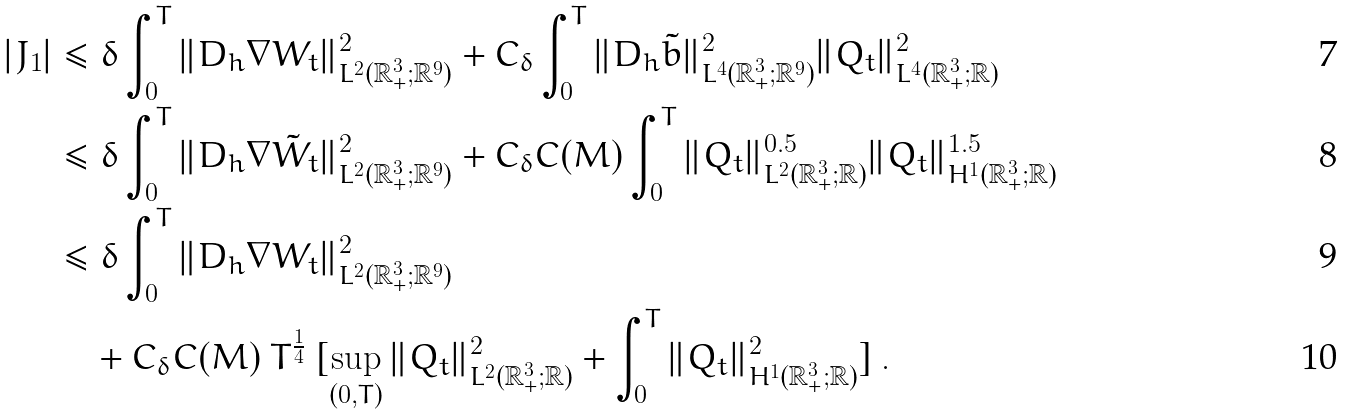Convert formula to latex. <formula><loc_0><loc_0><loc_500><loc_500>| J _ { 1 } | & \leq \delta \int _ { 0 } ^ { T } \| D _ { h } \nabla W _ { t } \| ^ { 2 } _ { L ^ { 2 } ( { \mathbb { R } } ^ { 3 } _ { + } ; { \mathbb { R } } ^ { 9 } ) } + C _ { \delta } \int _ { 0 } ^ { T } \| D _ { h } \tilde { b } \| ^ { 2 } _ { L ^ { 4 } ( { \mathbb { R } } ^ { 3 } _ { + } ; { \mathbb { R } } ^ { 9 } ) } \| Q _ { t } \| ^ { 2 } _ { L ^ { 4 } ( { \mathbb { R } } ^ { 3 } _ { + } ; { \mathbb { R } } ) } \\ & \leq \delta \int _ { 0 } ^ { T } \| D _ { h } \nabla \tilde { W } _ { t } \| ^ { 2 } _ { L ^ { 2 } ( { \mathbb { R } } ^ { 3 } _ { + } ; { \mathbb { R } } ^ { 9 } ) } + C _ { \delta } C ( M ) \int _ { 0 } ^ { T } \| Q _ { t } \| ^ { 0 . 5 } _ { L ^ { 2 } ( { \mathbb { R } } ^ { 3 } _ { + } ; { \mathbb { R } } ) } \| Q _ { t } \| ^ { 1 . 5 } _ { H ^ { 1 } ( { \mathbb { R } } ^ { 3 } _ { + } ; { \mathbb { R } } ) } \\ & \leq \delta \int _ { 0 } ^ { T } \| D _ { h } \nabla W _ { t } \| ^ { 2 } _ { L ^ { 2 } ( { \mathbb { R } } ^ { 3 } _ { + } ; { \mathbb { R } } ^ { 9 } ) } \\ & \quad + C _ { \delta } C ( M ) \ T ^ { \frac { 1 } { 4 } } \ [ \sup _ { ( 0 , T ) } \| Q _ { t } \| ^ { 2 } _ { L ^ { 2 } ( { \mathbb { R } } ^ { 3 } _ { + } ; { \mathbb { R } } ) } + \int _ { 0 } ^ { T } \| Q _ { t } \| ^ { 2 } _ { H ^ { 1 } ( { \mathbb { R } } ^ { 3 } _ { + } ; { \mathbb { R } } ) } ] \ .</formula> 